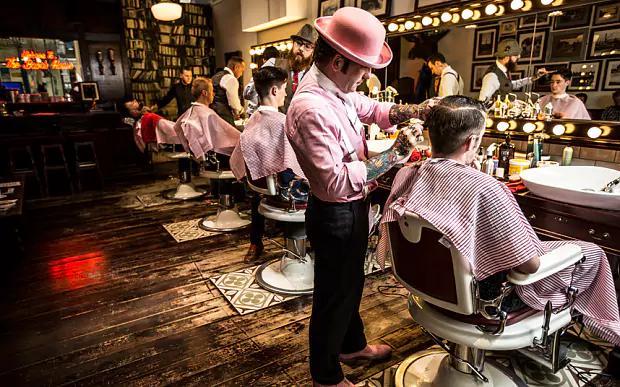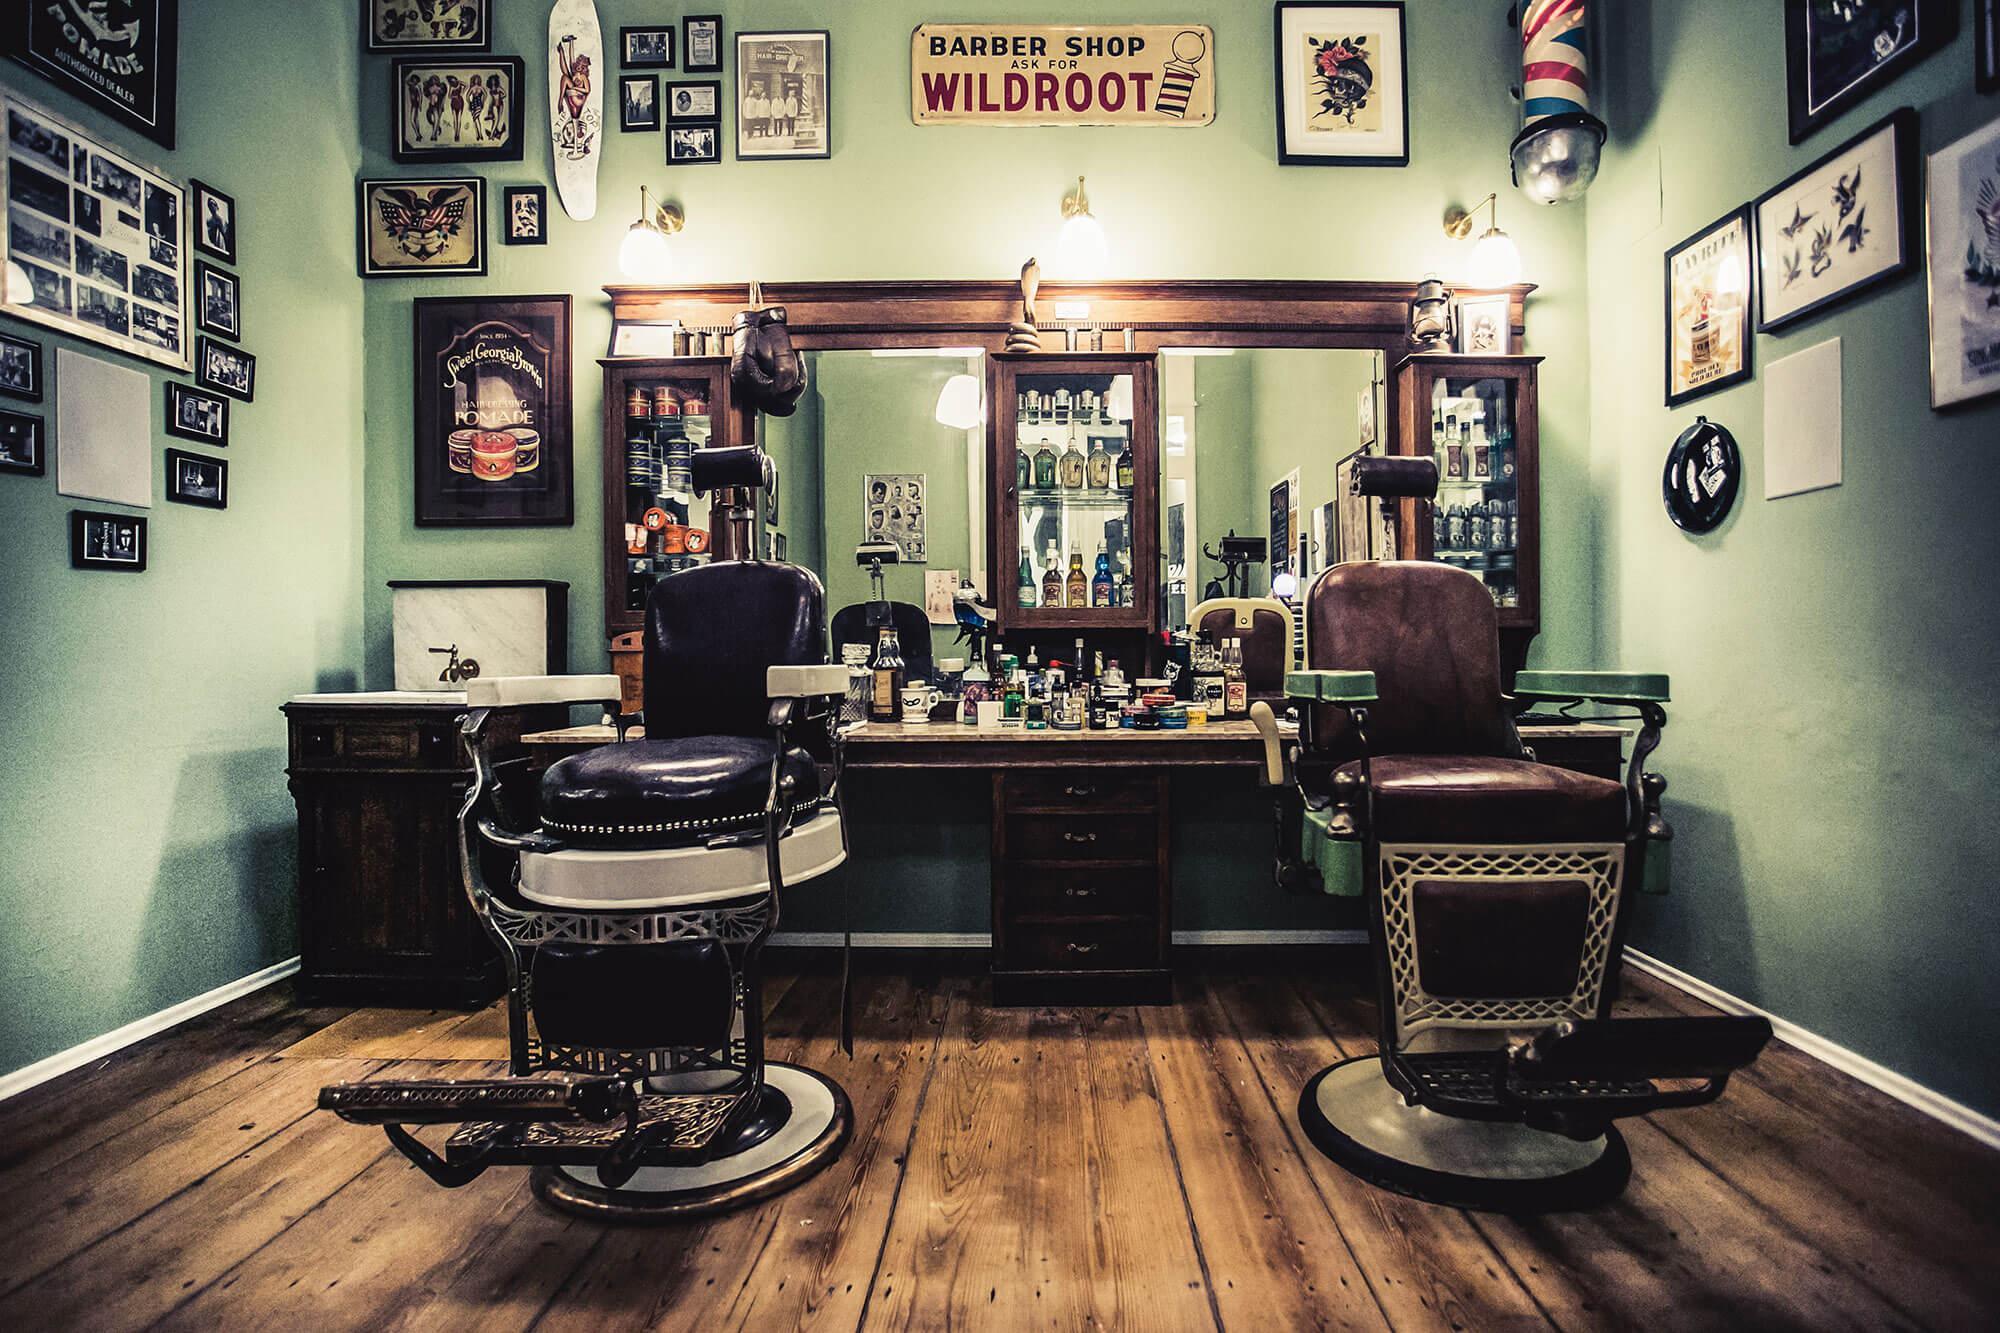The first image is the image on the left, the second image is the image on the right. For the images displayed, is the sentence "Barbers are cutting their clients' hair." factually correct? Answer yes or no. Yes. The first image is the image on the left, the second image is the image on the right. Given the left and right images, does the statement "An image shows barbers working on clients' hair." hold true? Answer yes or no. Yes. 